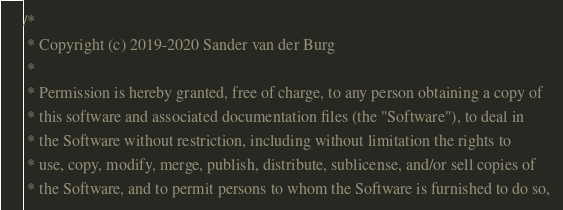<code> <loc_0><loc_0><loc_500><loc_500><_C_>/*
 * Copyright (c) 2019-2020 Sander van der Burg
 *
 * Permission is hereby granted, free of charge, to any person obtaining a copy of
 * this software and associated documentation files (the "Software"), to deal in
 * the Software without restriction, including without limitation the rights to
 * use, copy, modify, merge, publish, distribute, sublicense, and/or sell copies of
 * the Software, and to permit persons to whom the Software is furnished to do so, </code> 